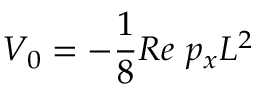Convert formula to latex. <formula><loc_0><loc_0><loc_500><loc_500>V _ { 0 } = - \frac { 1 } { 8 } R e \ p _ { x } L ^ { 2 }</formula> 